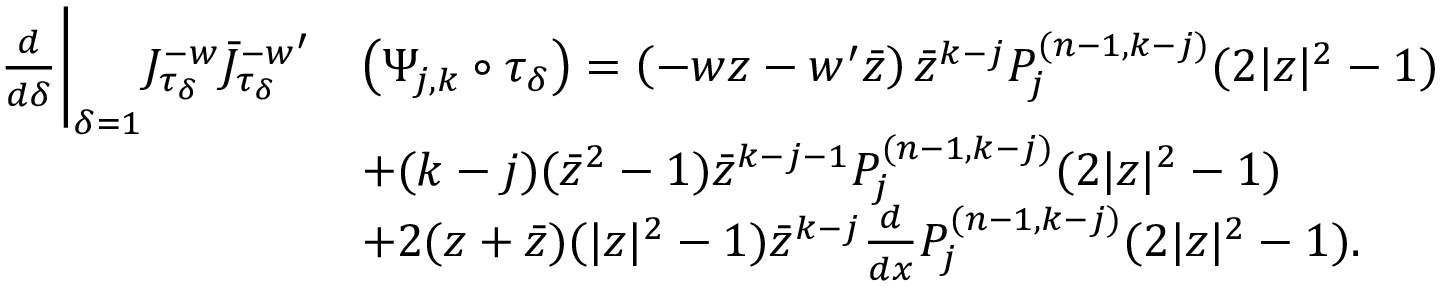<formula> <loc_0><loc_0><loc_500><loc_500>\begin{array} { r l } { \frac { d } { d \delta } \Big | _ { \delta = 1 } J _ { \tau _ { \delta } } ^ { - w } \bar { J } _ { \tau _ { \delta } } ^ { - w ^ { \prime } } } & { \left ( \Psi _ { j , k } \circ \tau _ { \delta } \right ) = \left ( - w z - w ^ { \prime } \bar { z } \right ) \bar { z } ^ { k - j } P _ { j } ^ { ( n - 1 , k - j ) } ( 2 | z | ^ { 2 } - 1 ) } \\ & { + ( k - j ) ( \bar { z } ^ { 2 } - 1 ) \bar { z } ^ { k - j - 1 } P _ { j } ^ { ( n - 1 , k - j ) } ( 2 | z | ^ { 2 } - 1 ) } \\ & { + 2 ( z + \bar { z } ) ( | z | ^ { 2 } - 1 ) \bar { z } ^ { k - j } \frac { d } { d x } P _ { j } ^ { ( n - 1 , k - j ) } ( 2 | z | ^ { 2 } - 1 ) . } \end{array}</formula> 